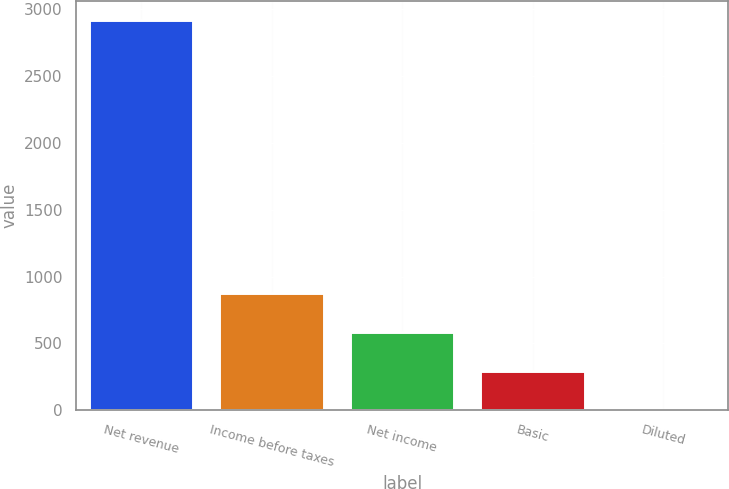Convert chart to OTSL. <chart><loc_0><loc_0><loc_500><loc_500><bar_chart><fcel>Net revenue<fcel>Income before taxes<fcel>Net income<fcel>Basic<fcel>Diluted<nl><fcel>2918<fcel>876.76<fcel>585.16<fcel>293.56<fcel>1.95<nl></chart> 